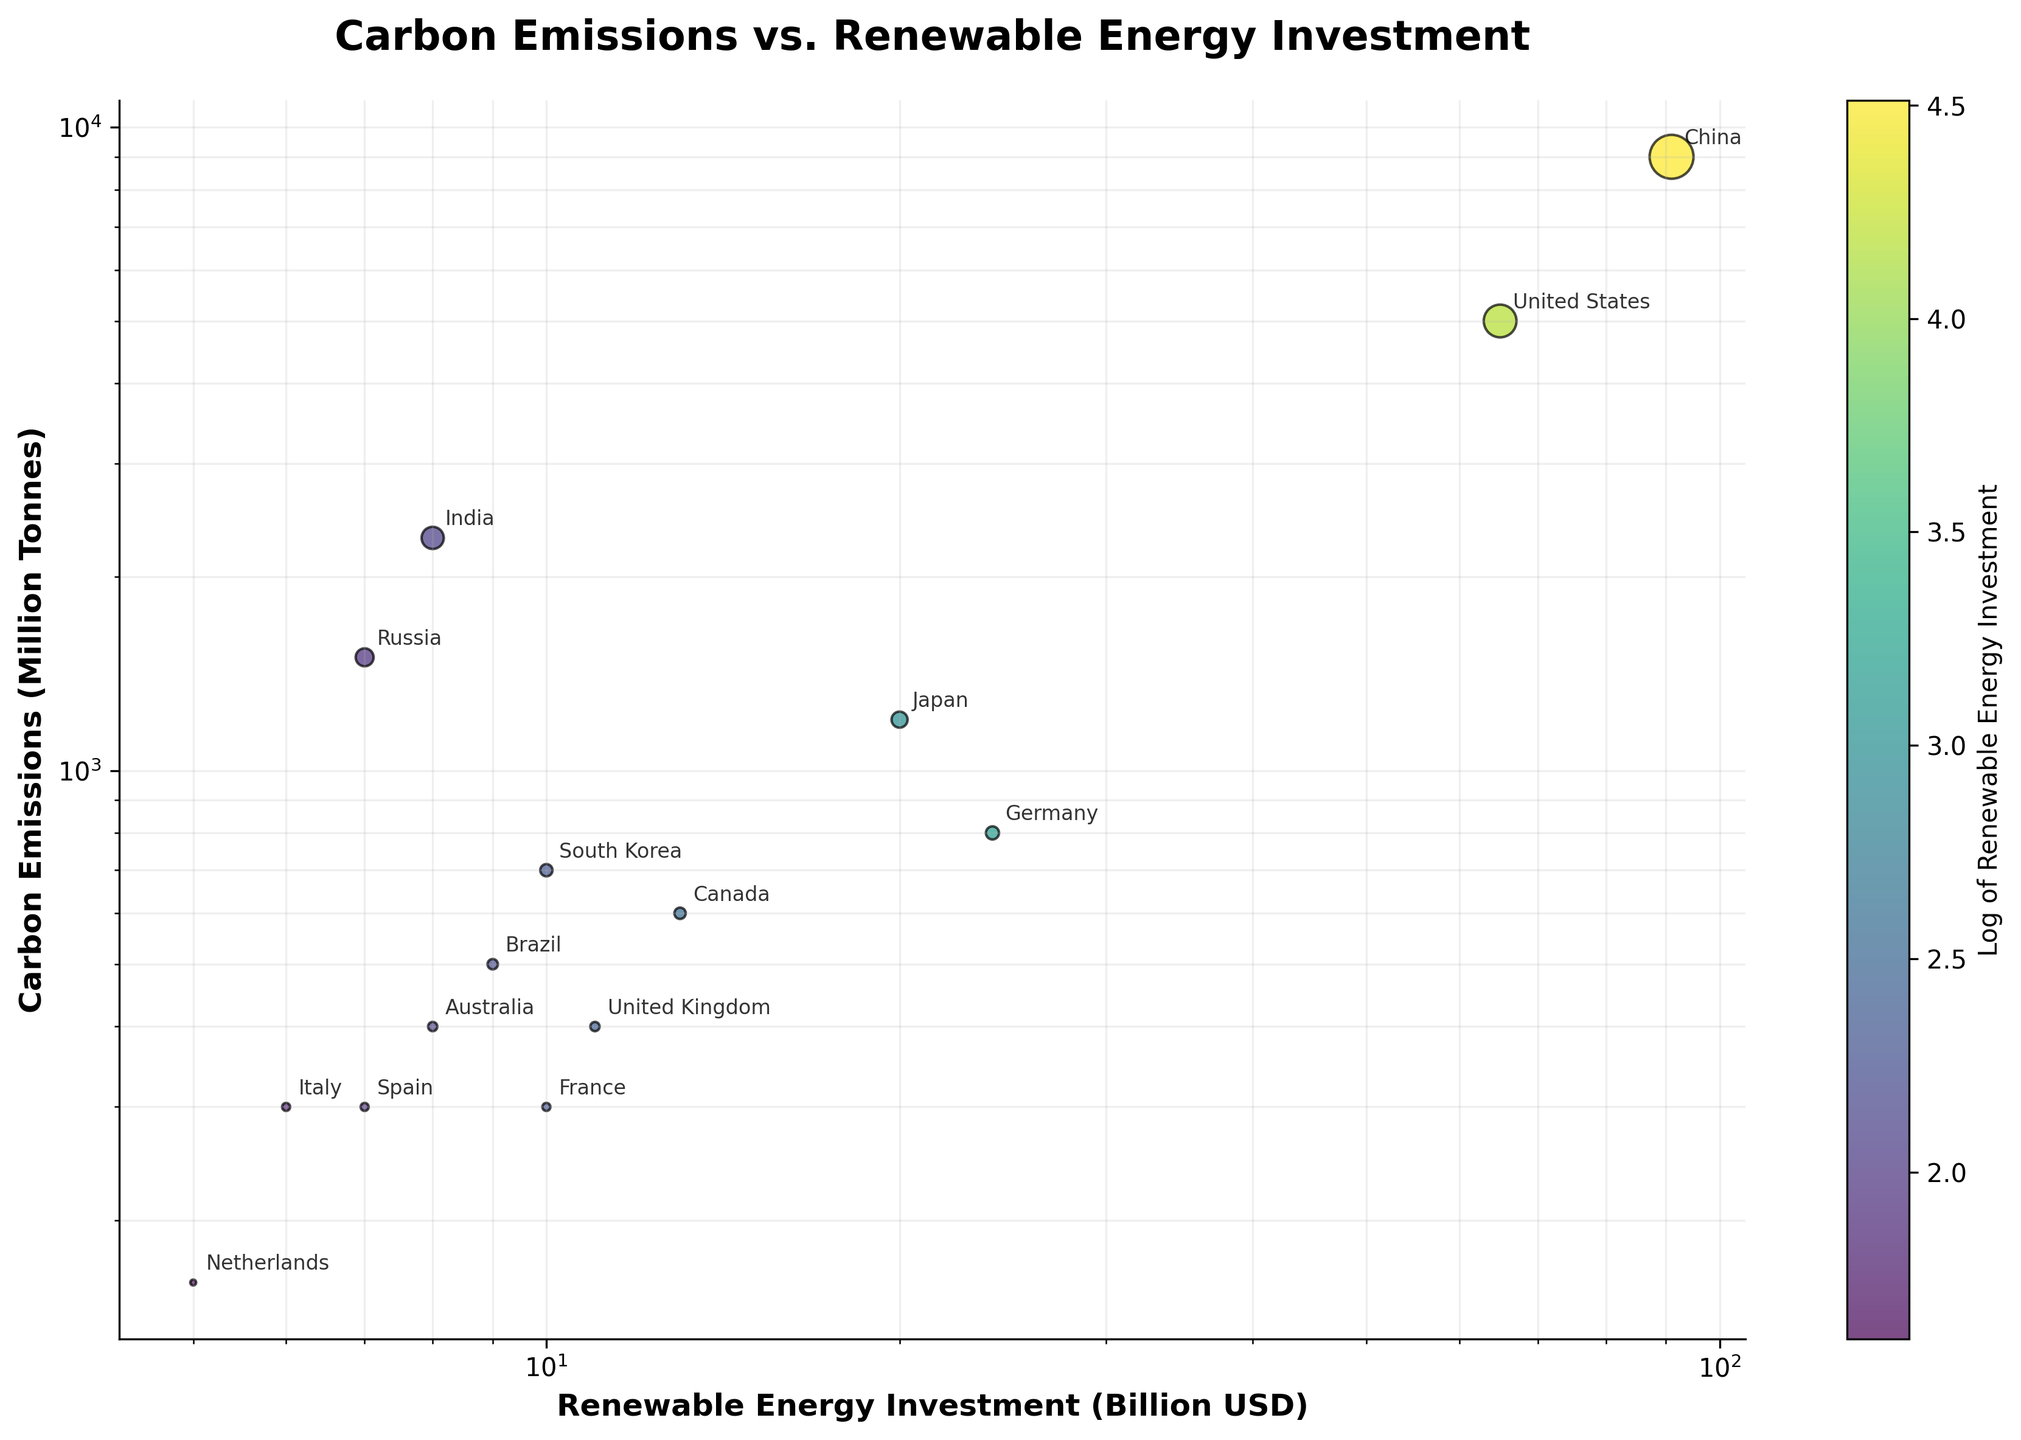Who has the highest carbon emissions? The figure shows China with the highest carbon emissions among the countries displayed. This can be seen by finding the highest point on the y-axis.
Answer: China What is the color gradient used in the scatter plot? The color gradient used ranges from a lighter to darker shade of a specific color, which is commonly associated with a palette that represents the log of renewable energy investment levels. This is confirmed by the color bar labeled "Log of Renewable Energy Investment."
Answer: Varying shades of viridis Which country has the smallest renewable energy investment? The country with the smallest renewable energy investment is found at the extreme left of the x-axis (since the axis is on a log scale). This country is Italy.
Answer: Italy Compare the carbon emissions between the United States and India. Which country has higher emissions? By locating both the United States and India on the y-axis, we observe that the United States has a higher y-value (carbon emissions) compared to India.
Answer: United States What is the relationship between renewable energy investment and carbon emissions for Germany? For Germany, located at around 24 billion USD on the x-axis and 800 million tonnes on the y-axis, it shows a moderate investment in renewables with lower emissions compared to major emitters like China and the USA.
Answer: Investments are moderate and emissions are lower relative to the highest emitters How many countries have carbon emissions less than 1000 million tonnes? By identifying all points below the 1000 million tonnes mark on the y-axis, there are ten countries: Germany, Brazil, United Kingdom, France, Canada, Australia, South Korea, Spain, Italy, and Netherlands.
Answer: Ten countries Is there a positive correlation between renewable energy investment and lower carbon emissions? By observing the scatter plot, countries with higher renewable energy investments such as Germany, United States, and China don’t strictly show lower emissions. However, countries with lower investments do generally have lower emissions indicating the correlation isn’t clear-cut. A direct positive correlation is not distinctly evident from the scatter plot.
Answer: No clear positive correlation Which two countries have the most similar renewable energy investment and carbon emissions? By identifying closely positioned points on both the x (investment) and y (emissions) axes, Japan and Germany show similar figures with Japan at 20 billion USD and 1200 million tonnes, and Germany at 24 billion USD and 800 million tonnes.
Answer: Japan and Germany 